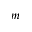<formula> <loc_0><loc_0><loc_500><loc_500>m</formula> 